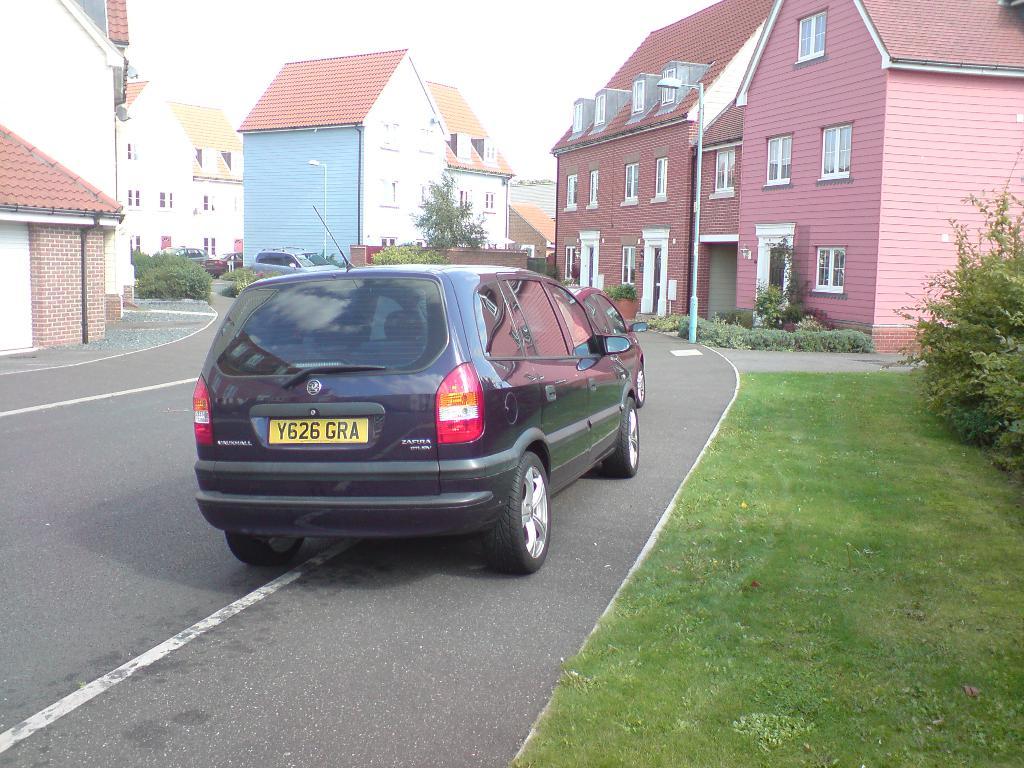What is the license plate number?
Provide a succinct answer. Y626 gra. What are the last 3 letters of the plate?
Make the answer very short. Gra. 